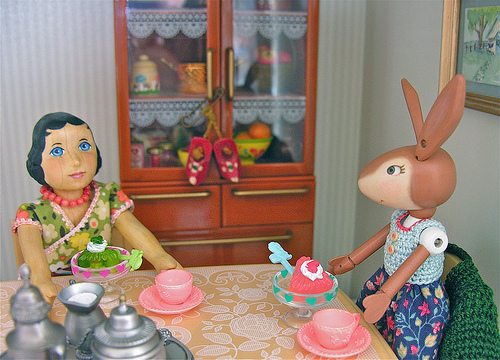<image>
Is there a rabbit to the right of the ice cream? Yes. From this viewpoint, the rabbit is positioned to the right side relative to the ice cream. Where is the rabbit in relation to the crochet? Is it in the crochet? Yes. The rabbit is contained within or inside the crochet, showing a containment relationship. Is the lady doll next to the rabbit doll? Yes. The lady doll is positioned adjacent to the rabbit doll, located nearby in the same general area. 